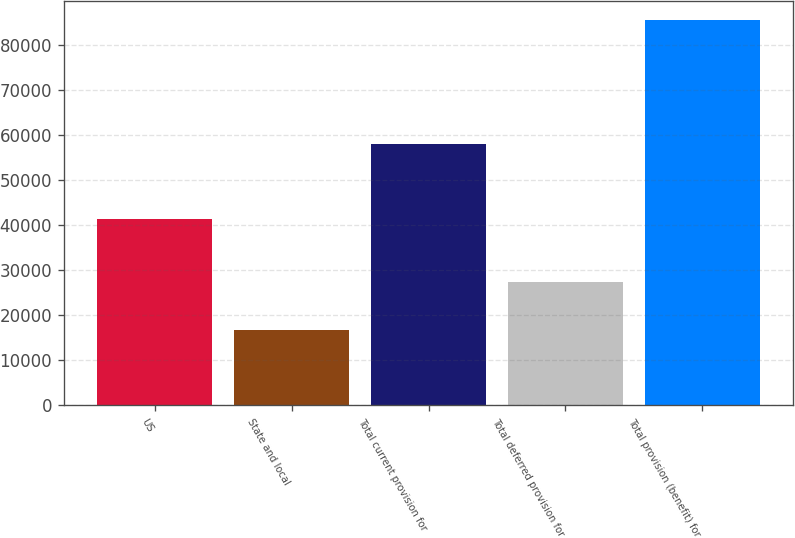Convert chart. <chart><loc_0><loc_0><loc_500><loc_500><bar_chart><fcel>US<fcel>State and local<fcel>Total current provision for<fcel>Total deferred provision for<fcel>Total provision (benefit) for<nl><fcel>41452<fcel>16678<fcel>58130<fcel>27347<fcel>85477<nl></chart> 